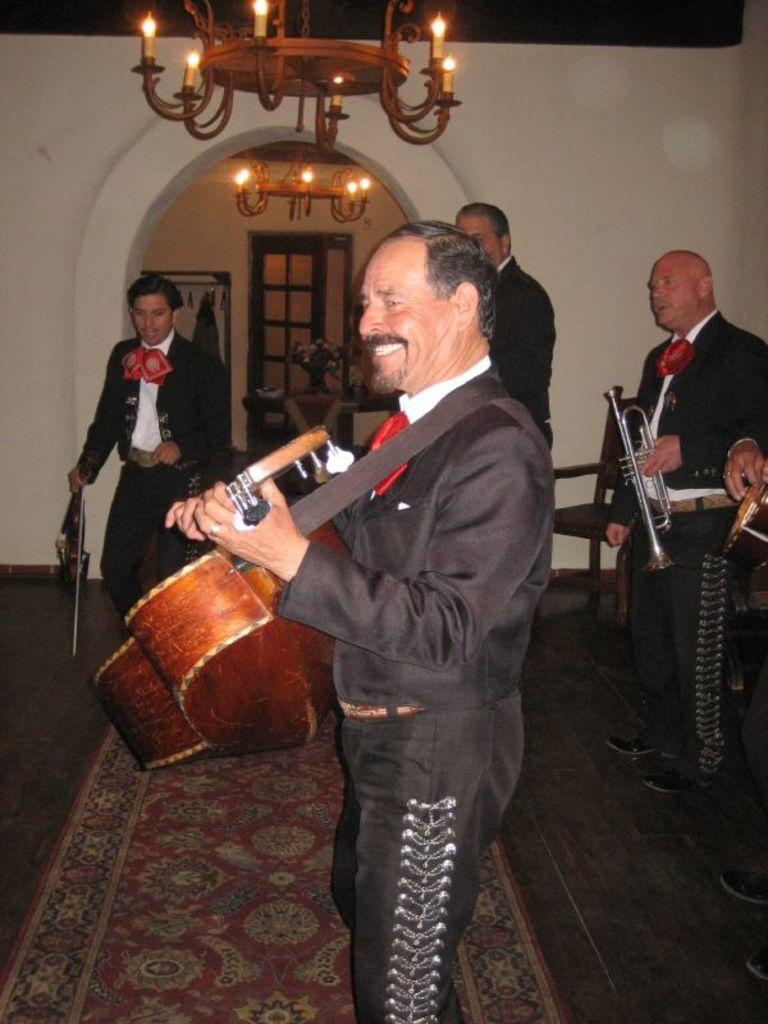How many people are in the image? There is a group of people in the image. What are the people doing in the image? The people are on the floor. What else can be seen in the image besides the people? There are musical instruments in the image. What can be seen in the background of the image? There is a wall, lights, and some objects in the background of the image. What type of hat is the person wearing while attacking the musical instruments in the image? There is no person wearing a hat or attacking any musical instruments in the image. 